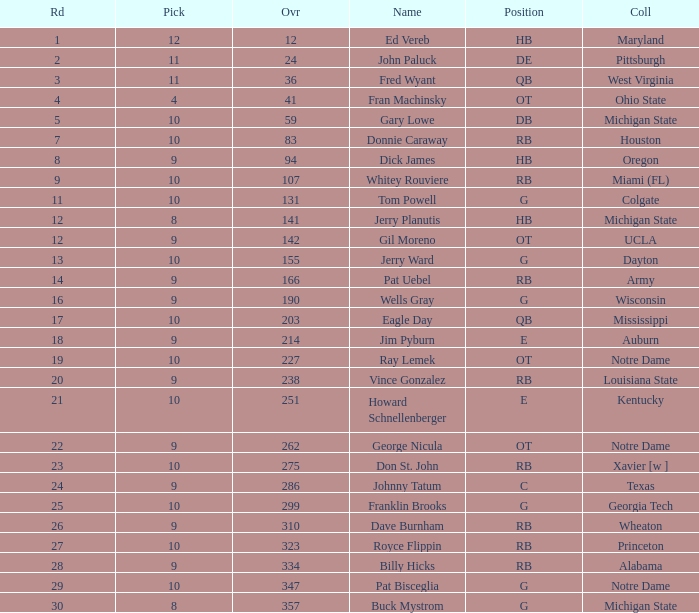What is the highest overall pick number for george nicula who had a pick smaller than 9? None. 